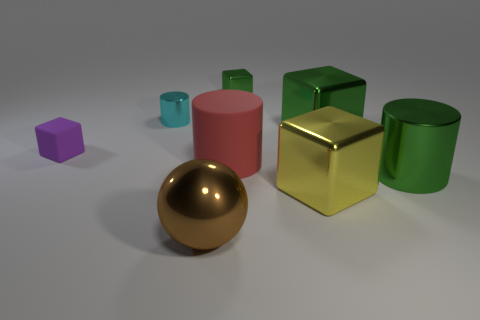Subtract all metallic cubes. How many cubes are left? 1 Subtract 1 spheres. How many spheres are left? 0 Add 3 brown metallic objects. How many brown metallic objects are left? 4 Add 7 green objects. How many green objects exist? 10 Add 1 large metal cylinders. How many objects exist? 9 Subtract all green cylinders. How many cylinders are left? 2 Subtract 0 purple cylinders. How many objects are left? 8 Subtract all spheres. How many objects are left? 7 Subtract all red cylinders. Subtract all gray blocks. How many cylinders are left? 2 Subtract all green cubes. How many cyan cylinders are left? 1 